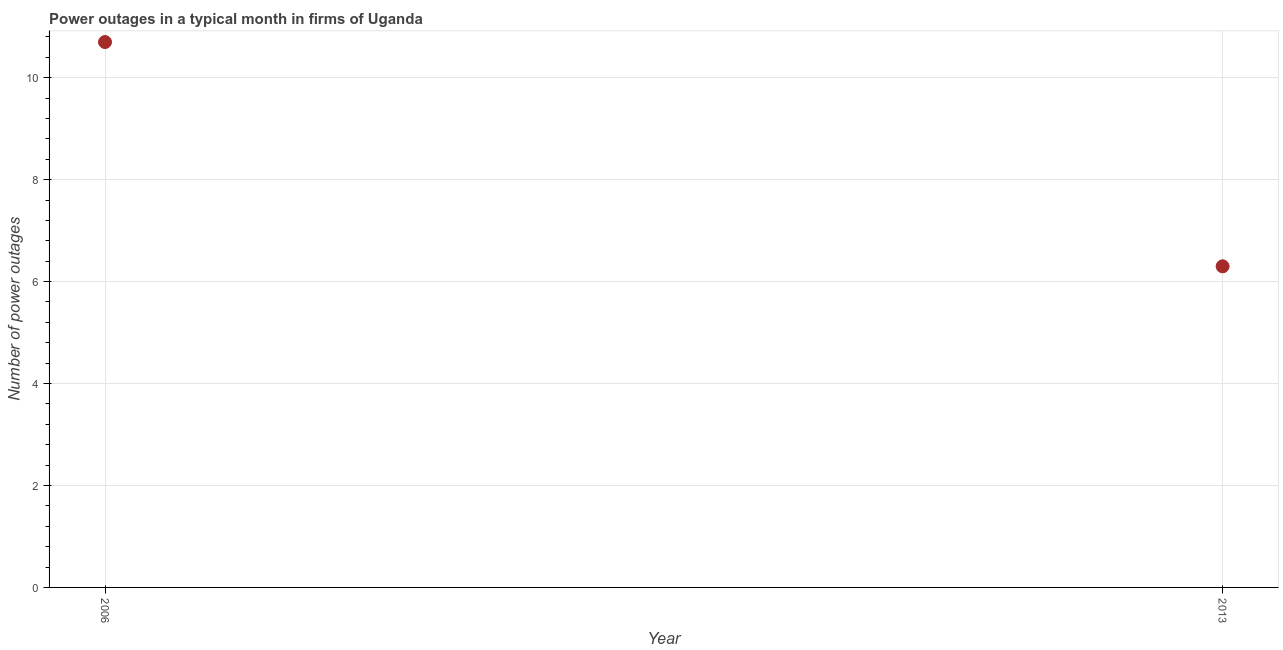Across all years, what is the minimum number of power outages?
Offer a very short reply. 6.3. In which year was the number of power outages maximum?
Provide a short and direct response. 2006. In which year was the number of power outages minimum?
Your answer should be compact. 2013. What is the sum of the number of power outages?
Keep it short and to the point. 17. What is the difference between the number of power outages in 2006 and 2013?
Provide a short and direct response. 4.4. What is the median number of power outages?
Provide a short and direct response. 8.5. What is the ratio of the number of power outages in 2006 to that in 2013?
Your response must be concise. 1.7. In how many years, is the number of power outages greater than the average number of power outages taken over all years?
Your answer should be very brief. 1. How many dotlines are there?
Provide a succinct answer. 1. Does the graph contain any zero values?
Make the answer very short. No. Does the graph contain grids?
Your answer should be very brief. Yes. What is the title of the graph?
Give a very brief answer. Power outages in a typical month in firms of Uganda. What is the label or title of the Y-axis?
Your answer should be compact. Number of power outages. What is the difference between the Number of power outages in 2006 and 2013?
Make the answer very short. 4.4. What is the ratio of the Number of power outages in 2006 to that in 2013?
Offer a very short reply. 1.7. 